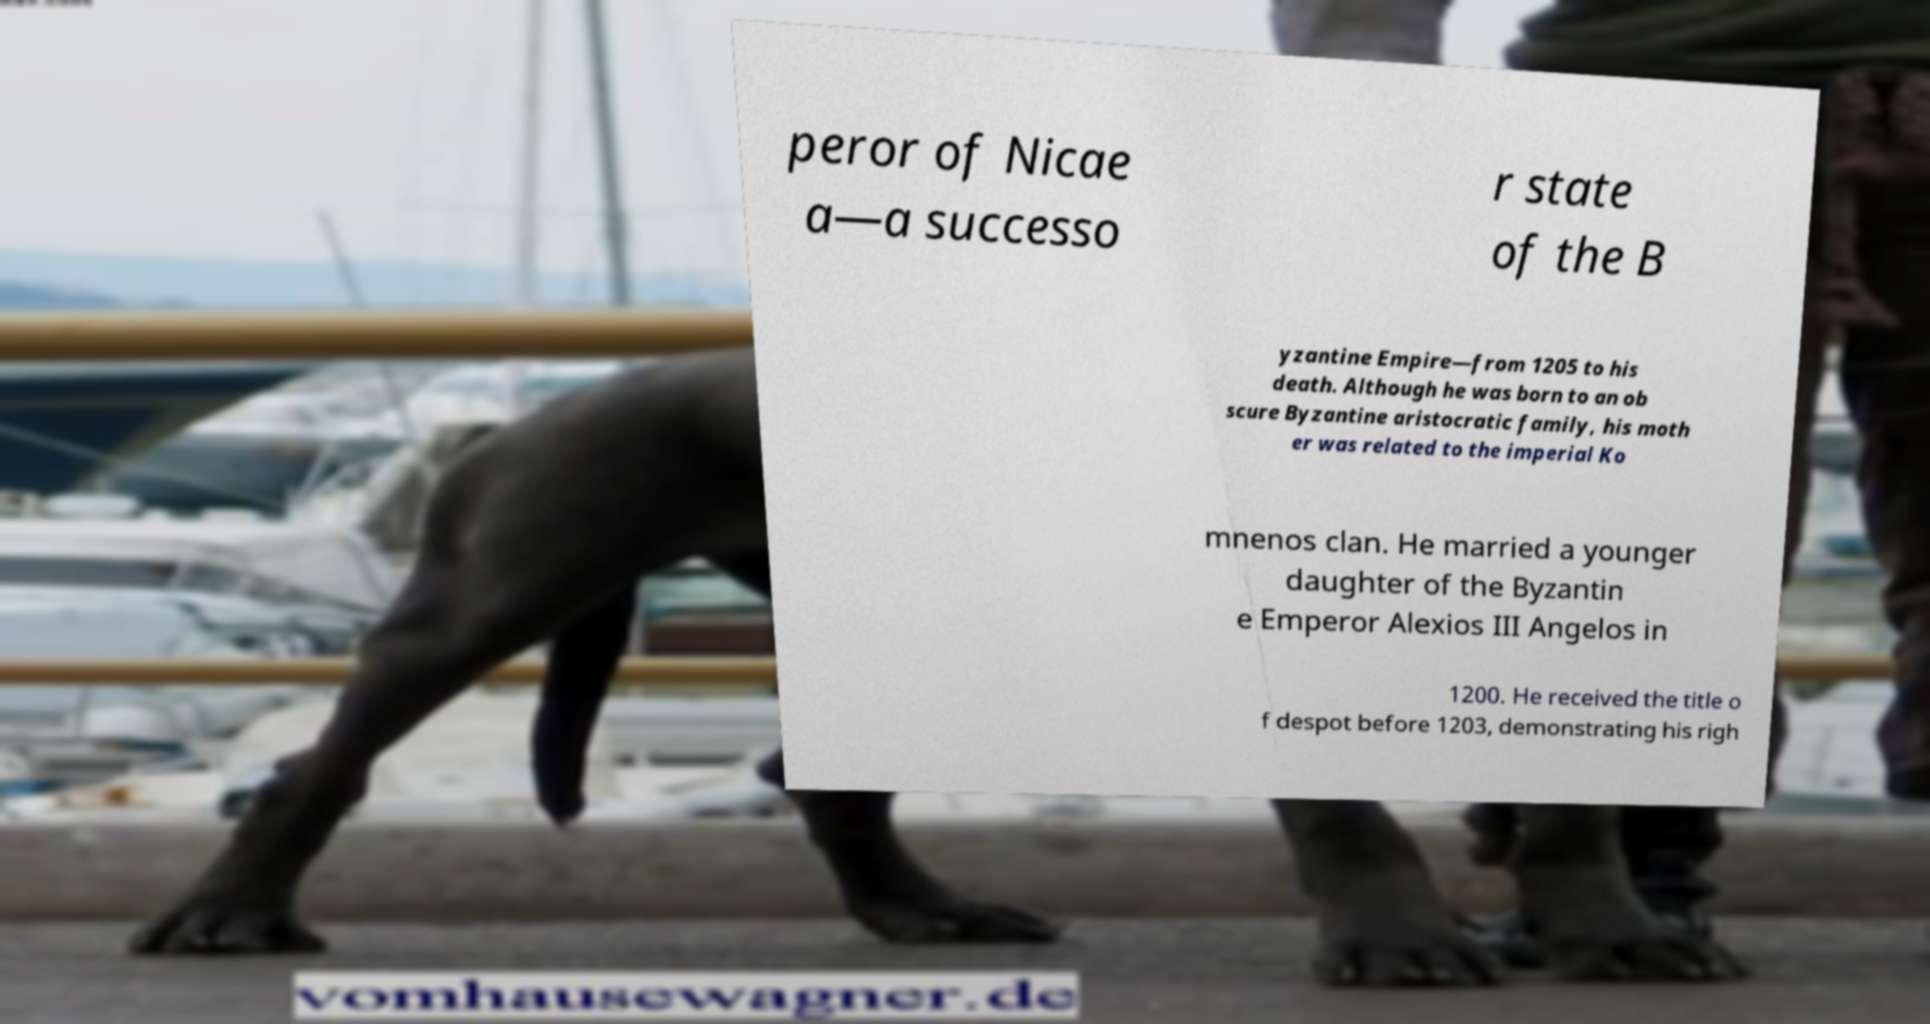Could you assist in decoding the text presented in this image and type it out clearly? peror of Nicae a—a successo r state of the B yzantine Empire—from 1205 to his death. Although he was born to an ob scure Byzantine aristocratic family, his moth er was related to the imperial Ko mnenos clan. He married a younger daughter of the Byzantin e Emperor Alexios III Angelos in 1200. He received the title o f despot before 1203, demonstrating his righ 